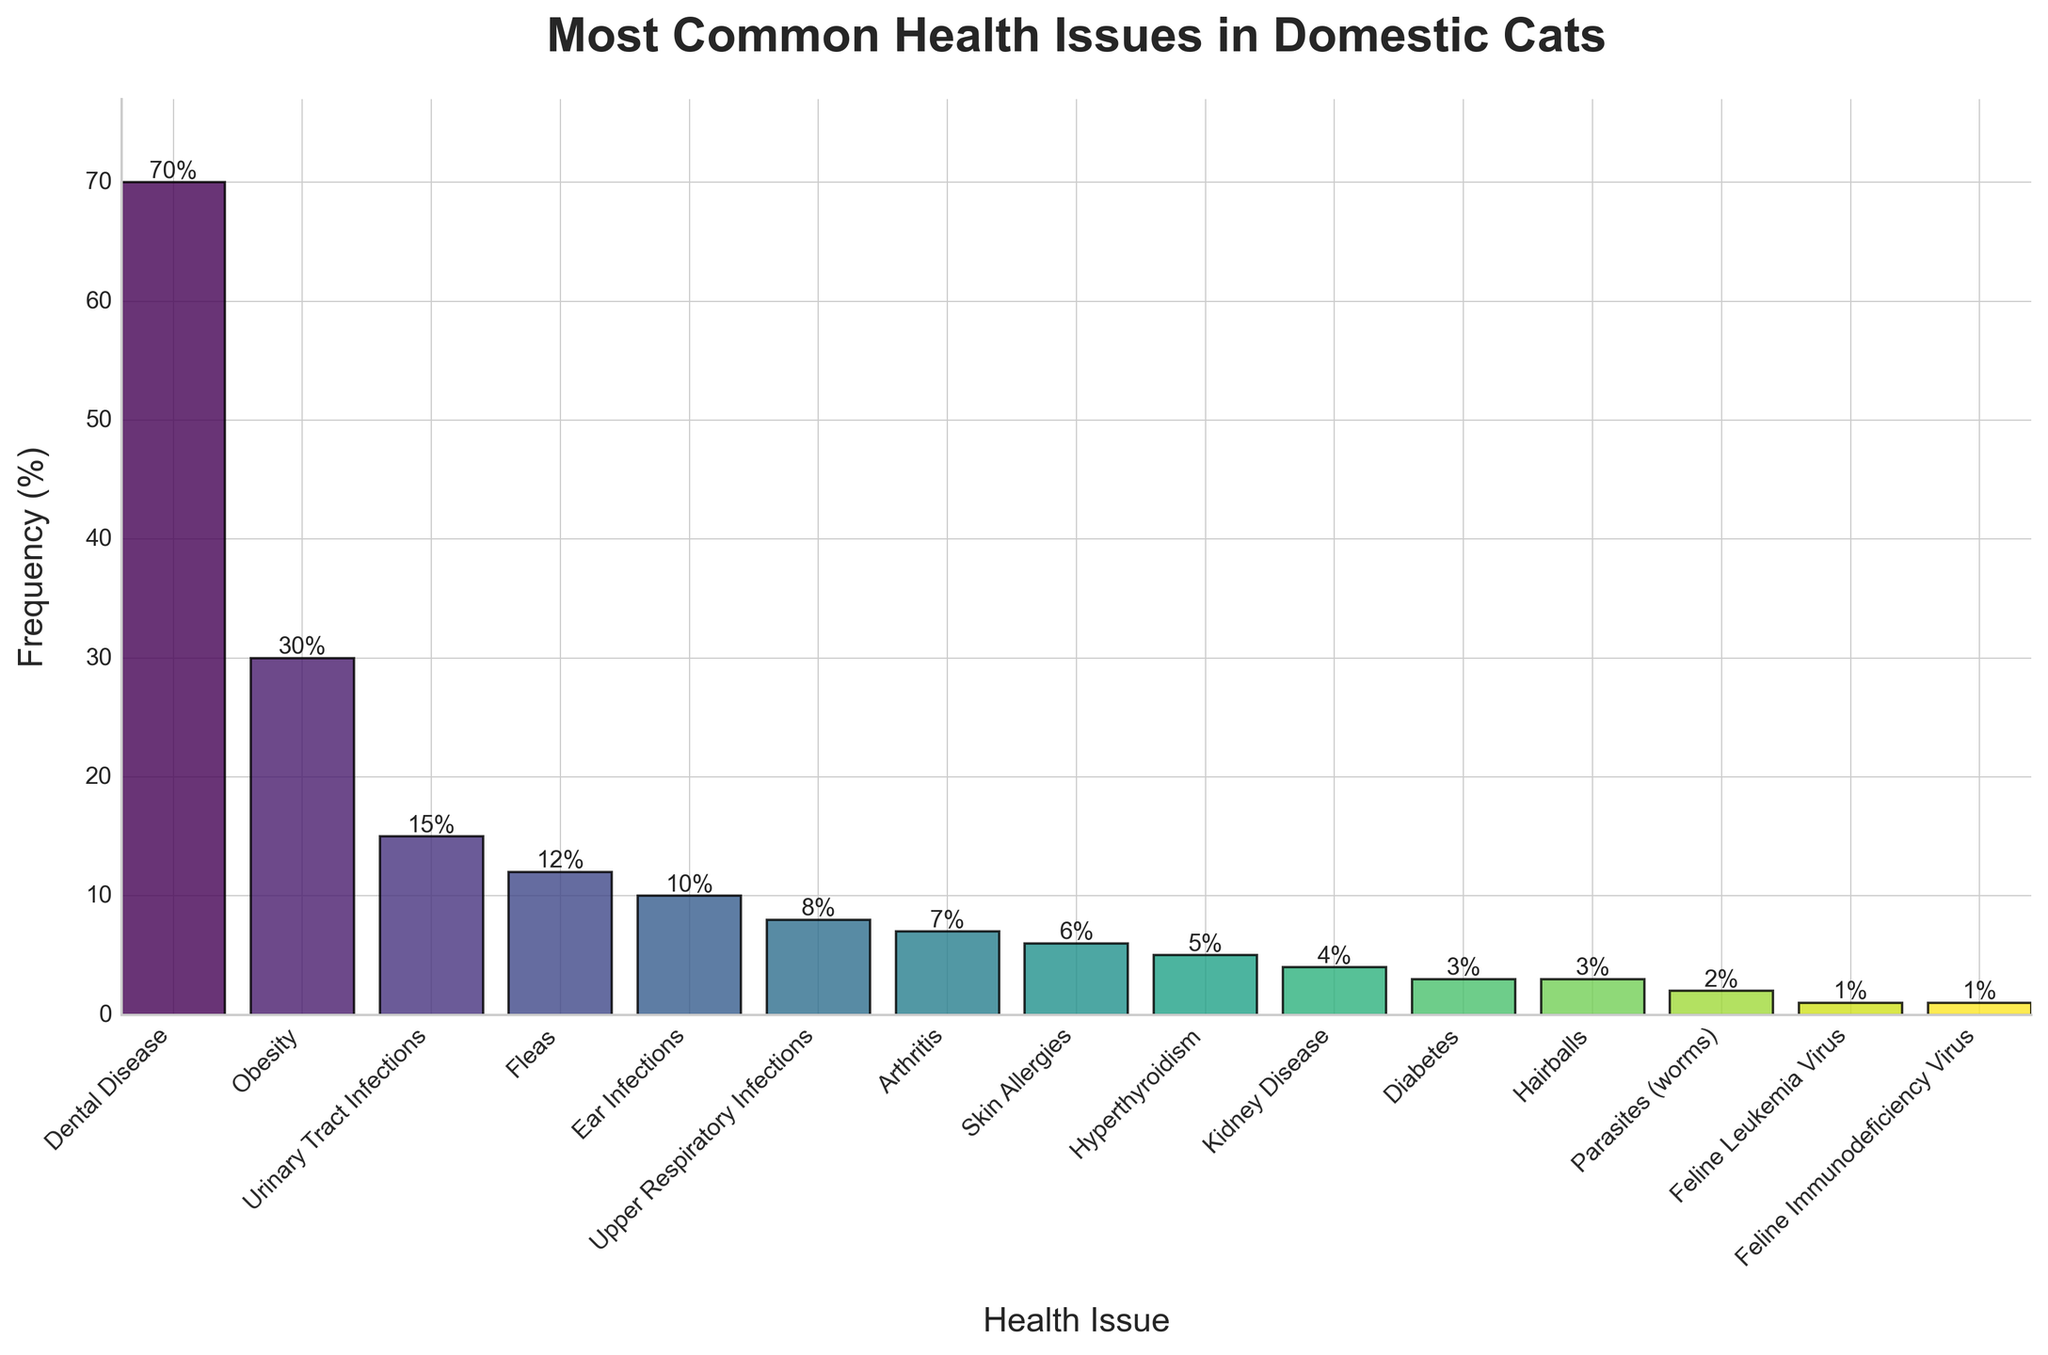What is the most common health issue in domestic cats? The most common health issue is represented by the tallest bar in the chart. The tallest bar corresponds to "Dental Disease" with a frequency of 70%.
Answer: Dental Disease Which health issue has a lower frequency: Fleas or Ear Infections? Comparing the heights of the bars for "Fleas" and "Ear Infections," "Fleas" has a frequency of 12% while "Ear Infections" has a frequency of 10%.
Answer: Ear Infections What is the total frequency percentage for Skin Allergies and Hyperthyroidism combined? The frequency for Skin Allergies is 6% and for Hyperthyroidism is 5%. Adding them gives: 6% + 5% = 11%.
Answer: 11% How much higher is the frequency of Arthritis compared to Hairballs? Arthritis has a frequency of 7%, while Hairballs have a frequency of 3%. Subtracting the two: 7% - 3% = 4%.
Answer: 4% What are the least common health issues presented and their frequencies? The least common issues are the ones with the smallest bars. Both "Feline Leukemia Virus" and "Feline Immunodeficiency Virus" have frequencies of 1%.
Answer: Feline Leukemia Virus, Feline Immunodeficiency Virus (1%) Which health issue has a frequency exactly half that of Obesity? The frequency of Obesity is 30%. Half of this value is 15%. The health issue with a frequency of 15% is "Urinary Tract Infections."
Answer: Urinary Tract Infections Compare the combined frequency of Dental Disease and Obesity with the combined frequency of Kidney Disease and Diabetes. Which is higher? Dental Disease has 70% and Obesity has 30%. Combined, that's 70% + 30% = 100%. Kidney Disease has 4% and Diabetes has 3%. Combined, that's 4% + 3% = 7%. 100% is greater than 7%.
Answer: Dental Disease and Obesity What is the frequency difference between Ear Infections and Upper Respiratory Infections? Ear Infections have a frequency of 10%, and Upper Respiratory Infections have 8%. The difference is 10% - 8% = 2%.
Answer: 2% Identify all health issues with frequencies lower than 5%. The health issues with frequencies lower than 5% are Diabetes (3%), Hairballs (3%), Parasites (worms) (2%), Feline Leukemia Virus (1%), and Feline Immunodeficiency Virus (1%).
Answer: Diabetes, Hairballs, Parasites (worms), Feline Leukemia Virus, Feline Immunodeficiency Virus What is the average frequency of the categories that have a frequency of 5% and above? The categories are Dental Disease (70%), Obesity (30%), Urinary Tract Infections (15%), Fleas (12%), Ear Infections (10%), Upper Respiratory Infections (8%), Arthritis (7%), Skin Allergies (6%), Hyperthyroidism (5%). Adding these: 70 + 30 + 15 + 12 + 10 + 8 + 7 + 6 + 5 = 163. There are 9 categories, so the average is 163 / 9 ≈ 18.11%.
Answer: 18.11% 